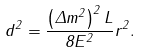Convert formula to latex. <formula><loc_0><loc_0><loc_500><loc_500>d ^ { 2 } = \frac { \left ( \Delta m ^ { 2 } \right ) ^ { 2 } L } { 8 E ^ { 2 } } r ^ { 2 } .</formula> 